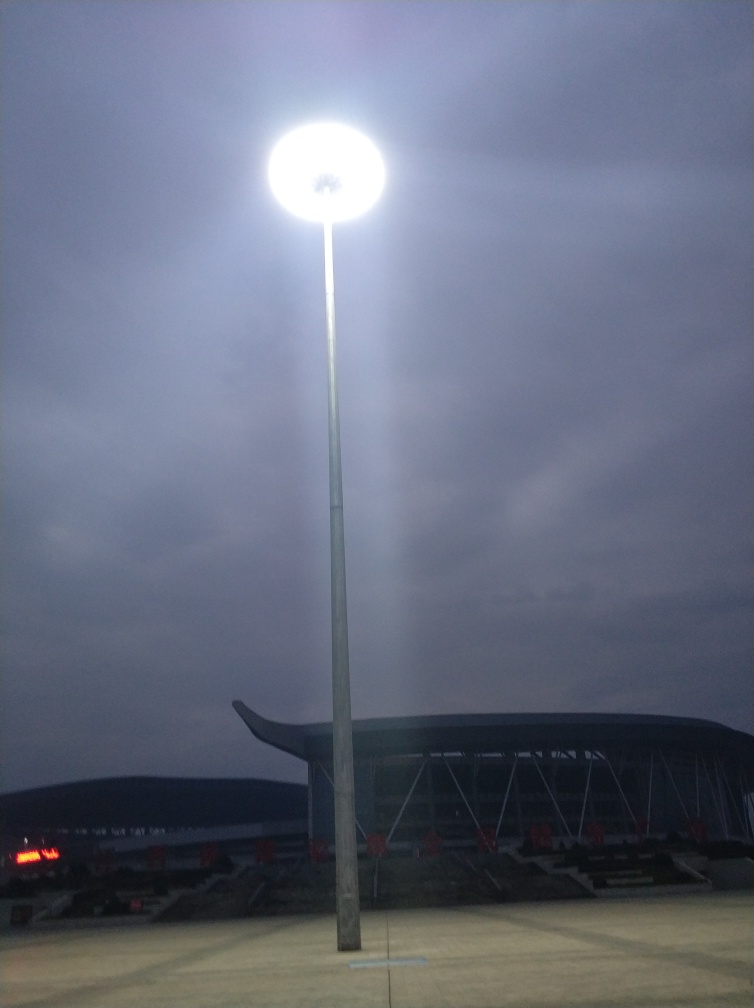Can you describe the weather conditions in this image? The image features an overcast sky, suggesting cloudy weather which could imply an imminent rain or a recent clearing of rain. 